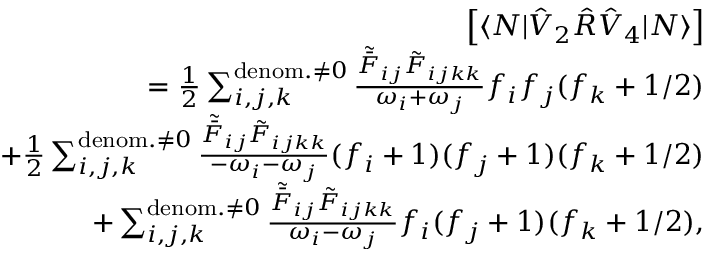Convert formula to latex. <formula><loc_0><loc_0><loc_500><loc_500>\begin{array} { r l r } & { \left [ \langle N | \hat { V } _ { 2 } \hat { R } \hat { V } _ { 4 } | N \rangle \right ] } \\ & { = \frac { 1 } { 2 } \sum _ { i , j , k } ^ { d e n o m . \neq 0 } \frac { \tilde { \bar { F } } _ { i j } \tilde { F } _ { i j k k } } { \omega _ { i } + \omega _ { j } } f _ { i } f _ { j } ( f _ { k } + 1 / 2 ) } \\ & { + \frac { 1 } { 2 } \sum _ { i , j , k } ^ { d e n o m . \neq 0 } \frac { \tilde { \bar { F } } _ { i j } \tilde { F } _ { i j k k } } { - \omega _ { i } - \omega _ { j } } ( f _ { i } + 1 ) ( f _ { j } + 1 ) ( f _ { k } + 1 / 2 ) } \\ & { + \sum _ { i , j , k } ^ { d e n o m . \neq 0 } \frac { \tilde { \bar { F } } _ { i j } \tilde { F } _ { i j k k } } { \omega _ { i } - \omega _ { j } } f _ { i } ( f _ { j } + 1 ) ( f _ { k } + 1 / 2 ) , } \end{array}</formula> 